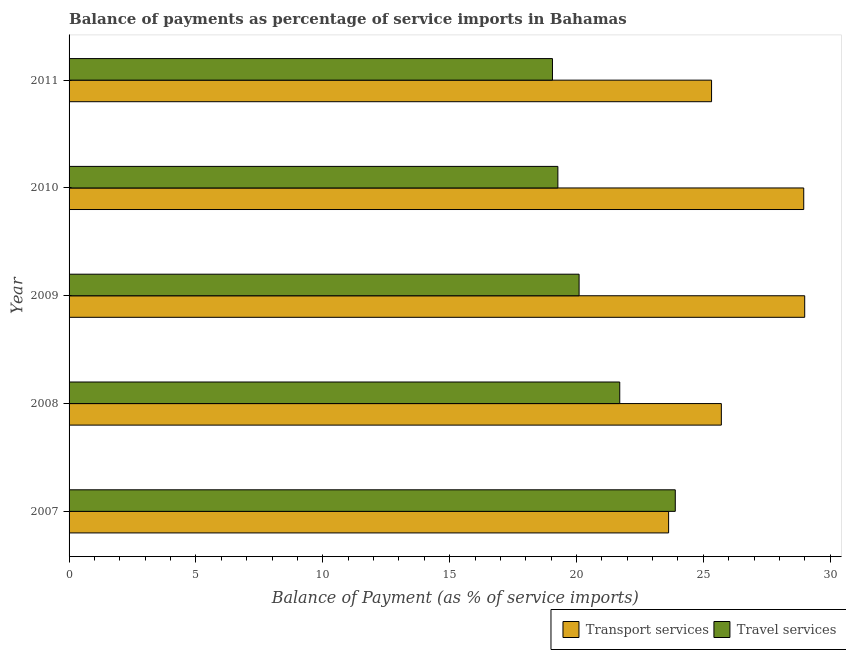How many different coloured bars are there?
Offer a very short reply. 2. How many groups of bars are there?
Offer a terse response. 5. Are the number of bars on each tick of the Y-axis equal?
Your response must be concise. Yes. What is the label of the 3rd group of bars from the top?
Provide a succinct answer. 2009. What is the balance of payments of travel services in 2008?
Ensure brevity in your answer.  21.71. Across all years, what is the maximum balance of payments of travel services?
Provide a succinct answer. 23.89. Across all years, what is the minimum balance of payments of transport services?
Ensure brevity in your answer.  23.63. In which year was the balance of payments of travel services minimum?
Offer a very short reply. 2011. What is the total balance of payments of travel services in the graph?
Make the answer very short. 104.02. What is the difference between the balance of payments of travel services in 2007 and that in 2009?
Keep it short and to the point. 3.79. What is the difference between the balance of payments of travel services in 2011 and the balance of payments of transport services in 2010?
Give a very brief answer. -9.9. What is the average balance of payments of travel services per year?
Give a very brief answer. 20.8. In the year 2010, what is the difference between the balance of payments of travel services and balance of payments of transport services?
Your answer should be compact. -9.69. In how many years, is the balance of payments of transport services greater than 13 %?
Give a very brief answer. 5. What is the ratio of the balance of payments of travel services in 2009 to that in 2011?
Keep it short and to the point. 1.05. Is the balance of payments of transport services in 2010 less than that in 2011?
Your answer should be compact. No. What is the difference between the highest and the second highest balance of payments of transport services?
Ensure brevity in your answer.  0.04. What is the difference between the highest and the lowest balance of payments of travel services?
Give a very brief answer. 4.84. Is the sum of the balance of payments of transport services in 2007 and 2010 greater than the maximum balance of payments of travel services across all years?
Provide a succinct answer. Yes. What does the 2nd bar from the top in 2010 represents?
Your response must be concise. Transport services. What does the 1st bar from the bottom in 2011 represents?
Ensure brevity in your answer.  Transport services. How many bars are there?
Your answer should be compact. 10. Are all the bars in the graph horizontal?
Your response must be concise. Yes. What is the difference between two consecutive major ticks on the X-axis?
Your response must be concise. 5. Where does the legend appear in the graph?
Ensure brevity in your answer.  Bottom right. How many legend labels are there?
Give a very brief answer. 2. What is the title of the graph?
Offer a very short reply. Balance of payments as percentage of service imports in Bahamas. What is the label or title of the X-axis?
Provide a succinct answer. Balance of Payment (as % of service imports). What is the label or title of the Y-axis?
Provide a succinct answer. Year. What is the Balance of Payment (as % of service imports) in Transport services in 2007?
Ensure brevity in your answer.  23.63. What is the Balance of Payment (as % of service imports) in Travel services in 2007?
Give a very brief answer. 23.89. What is the Balance of Payment (as % of service imports) in Transport services in 2008?
Your response must be concise. 25.71. What is the Balance of Payment (as % of service imports) in Travel services in 2008?
Keep it short and to the point. 21.71. What is the Balance of Payment (as % of service imports) in Transport services in 2009?
Provide a succinct answer. 29. What is the Balance of Payment (as % of service imports) in Travel services in 2009?
Provide a succinct answer. 20.1. What is the Balance of Payment (as % of service imports) in Transport services in 2010?
Give a very brief answer. 28.96. What is the Balance of Payment (as % of service imports) in Travel services in 2010?
Your answer should be very brief. 19.27. What is the Balance of Payment (as % of service imports) of Transport services in 2011?
Ensure brevity in your answer.  25.32. What is the Balance of Payment (as % of service imports) in Travel services in 2011?
Your answer should be compact. 19.05. Across all years, what is the maximum Balance of Payment (as % of service imports) of Transport services?
Make the answer very short. 29. Across all years, what is the maximum Balance of Payment (as % of service imports) in Travel services?
Your response must be concise. 23.89. Across all years, what is the minimum Balance of Payment (as % of service imports) of Transport services?
Keep it short and to the point. 23.63. Across all years, what is the minimum Balance of Payment (as % of service imports) of Travel services?
Offer a very short reply. 19.05. What is the total Balance of Payment (as % of service imports) in Transport services in the graph?
Keep it short and to the point. 132.62. What is the total Balance of Payment (as % of service imports) of Travel services in the graph?
Your answer should be compact. 104.02. What is the difference between the Balance of Payment (as % of service imports) in Transport services in 2007 and that in 2008?
Provide a succinct answer. -2.08. What is the difference between the Balance of Payment (as % of service imports) of Travel services in 2007 and that in 2008?
Your answer should be very brief. 2.19. What is the difference between the Balance of Payment (as % of service imports) of Transport services in 2007 and that in 2009?
Give a very brief answer. -5.36. What is the difference between the Balance of Payment (as % of service imports) in Travel services in 2007 and that in 2009?
Keep it short and to the point. 3.79. What is the difference between the Balance of Payment (as % of service imports) of Transport services in 2007 and that in 2010?
Offer a terse response. -5.33. What is the difference between the Balance of Payment (as % of service imports) in Travel services in 2007 and that in 2010?
Ensure brevity in your answer.  4.63. What is the difference between the Balance of Payment (as % of service imports) of Transport services in 2007 and that in 2011?
Offer a terse response. -1.69. What is the difference between the Balance of Payment (as % of service imports) of Travel services in 2007 and that in 2011?
Offer a terse response. 4.84. What is the difference between the Balance of Payment (as % of service imports) of Transport services in 2008 and that in 2009?
Give a very brief answer. -3.29. What is the difference between the Balance of Payment (as % of service imports) of Travel services in 2008 and that in 2009?
Provide a short and direct response. 1.6. What is the difference between the Balance of Payment (as % of service imports) in Transport services in 2008 and that in 2010?
Keep it short and to the point. -3.25. What is the difference between the Balance of Payment (as % of service imports) of Travel services in 2008 and that in 2010?
Your answer should be compact. 2.44. What is the difference between the Balance of Payment (as % of service imports) of Transport services in 2008 and that in 2011?
Offer a terse response. 0.39. What is the difference between the Balance of Payment (as % of service imports) in Travel services in 2008 and that in 2011?
Provide a succinct answer. 2.65. What is the difference between the Balance of Payment (as % of service imports) in Transport services in 2009 and that in 2010?
Your answer should be compact. 0.04. What is the difference between the Balance of Payment (as % of service imports) in Travel services in 2009 and that in 2010?
Your response must be concise. 0.84. What is the difference between the Balance of Payment (as % of service imports) in Transport services in 2009 and that in 2011?
Offer a very short reply. 3.67. What is the difference between the Balance of Payment (as % of service imports) of Travel services in 2009 and that in 2011?
Make the answer very short. 1.05. What is the difference between the Balance of Payment (as % of service imports) of Transport services in 2010 and that in 2011?
Provide a succinct answer. 3.63. What is the difference between the Balance of Payment (as % of service imports) of Travel services in 2010 and that in 2011?
Ensure brevity in your answer.  0.21. What is the difference between the Balance of Payment (as % of service imports) in Transport services in 2007 and the Balance of Payment (as % of service imports) in Travel services in 2008?
Your answer should be very brief. 1.93. What is the difference between the Balance of Payment (as % of service imports) in Transport services in 2007 and the Balance of Payment (as % of service imports) in Travel services in 2009?
Provide a short and direct response. 3.53. What is the difference between the Balance of Payment (as % of service imports) of Transport services in 2007 and the Balance of Payment (as % of service imports) of Travel services in 2010?
Keep it short and to the point. 4.36. What is the difference between the Balance of Payment (as % of service imports) of Transport services in 2007 and the Balance of Payment (as % of service imports) of Travel services in 2011?
Give a very brief answer. 4.58. What is the difference between the Balance of Payment (as % of service imports) of Transport services in 2008 and the Balance of Payment (as % of service imports) of Travel services in 2009?
Ensure brevity in your answer.  5.61. What is the difference between the Balance of Payment (as % of service imports) in Transport services in 2008 and the Balance of Payment (as % of service imports) in Travel services in 2010?
Your answer should be compact. 6.44. What is the difference between the Balance of Payment (as % of service imports) of Transport services in 2008 and the Balance of Payment (as % of service imports) of Travel services in 2011?
Ensure brevity in your answer.  6.66. What is the difference between the Balance of Payment (as % of service imports) in Transport services in 2009 and the Balance of Payment (as % of service imports) in Travel services in 2010?
Give a very brief answer. 9.73. What is the difference between the Balance of Payment (as % of service imports) of Transport services in 2009 and the Balance of Payment (as % of service imports) of Travel services in 2011?
Your response must be concise. 9.94. What is the difference between the Balance of Payment (as % of service imports) of Transport services in 2010 and the Balance of Payment (as % of service imports) of Travel services in 2011?
Offer a very short reply. 9.9. What is the average Balance of Payment (as % of service imports) of Transport services per year?
Ensure brevity in your answer.  26.52. What is the average Balance of Payment (as % of service imports) of Travel services per year?
Give a very brief answer. 20.8. In the year 2007, what is the difference between the Balance of Payment (as % of service imports) of Transport services and Balance of Payment (as % of service imports) of Travel services?
Keep it short and to the point. -0.26. In the year 2008, what is the difference between the Balance of Payment (as % of service imports) in Transport services and Balance of Payment (as % of service imports) in Travel services?
Keep it short and to the point. 4. In the year 2009, what is the difference between the Balance of Payment (as % of service imports) of Transport services and Balance of Payment (as % of service imports) of Travel services?
Your answer should be compact. 8.89. In the year 2010, what is the difference between the Balance of Payment (as % of service imports) of Transport services and Balance of Payment (as % of service imports) of Travel services?
Your response must be concise. 9.69. In the year 2011, what is the difference between the Balance of Payment (as % of service imports) in Transport services and Balance of Payment (as % of service imports) in Travel services?
Ensure brevity in your answer.  6.27. What is the ratio of the Balance of Payment (as % of service imports) of Transport services in 2007 to that in 2008?
Keep it short and to the point. 0.92. What is the ratio of the Balance of Payment (as % of service imports) of Travel services in 2007 to that in 2008?
Give a very brief answer. 1.1. What is the ratio of the Balance of Payment (as % of service imports) of Transport services in 2007 to that in 2009?
Provide a succinct answer. 0.81. What is the ratio of the Balance of Payment (as % of service imports) of Travel services in 2007 to that in 2009?
Offer a very short reply. 1.19. What is the ratio of the Balance of Payment (as % of service imports) of Transport services in 2007 to that in 2010?
Offer a very short reply. 0.82. What is the ratio of the Balance of Payment (as % of service imports) of Travel services in 2007 to that in 2010?
Ensure brevity in your answer.  1.24. What is the ratio of the Balance of Payment (as % of service imports) of Transport services in 2007 to that in 2011?
Your response must be concise. 0.93. What is the ratio of the Balance of Payment (as % of service imports) in Travel services in 2007 to that in 2011?
Provide a short and direct response. 1.25. What is the ratio of the Balance of Payment (as % of service imports) of Transport services in 2008 to that in 2009?
Your answer should be compact. 0.89. What is the ratio of the Balance of Payment (as % of service imports) in Travel services in 2008 to that in 2009?
Your answer should be compact. 1.08. What is the ratio of the Balance of Payment (as % of service imports) of Transport services in 2008 to that in 2010?
Offer a very short reply. 0.89. What is the ratio of the Balance of Payment (as % of service imports) of Travel services in 2008 to that in 2010?
Offer a terse response. 1.13. What is the ratio of the Balance of Payment (as % of service imports) of Transport services in 2008 to that in 2011?
Provide a short and direct response. 1.02. What is the ratio of the Balance of Payment (as % of service imports) in Travel services in 2008 to that in 2011?
Provide a succinct answer. 1.14. What is the ratio of the Balance of Payment (as % of service imports) of Travel services in 2009 to that in 2010?
Your answer should be compact. 1.04. What is the ratio of the Balance of Payment (as % of service imports) in Transport services in 2009 to that in 2011?
Your answer should be compact. 1.15. What is the ratio of the Balance of Payment (as % of service imports) in Travel services in 2009 to that in 2011?
Ensure brevity in your answer.  1.06. What is the ratio of the Balance of Payment (as % of service imports) of Transport services in 2010 to that in 2011?
Make the answer very short. 1.14. What is the ratio of the Balance of Payment (as % of service imports) in Travel services in 2010 to that in 2011?
Provide a succinct answer. 1.01. What is the difference between the highest and the second highest Balance of Payment (as % of service imports) of Transport services?
Keep it short and to the point. 0.04. What is the difference between the highest and the second highest Balance of Payment (as % of service imports) of Travel services?
Your answer should be compact. 2.19. What is the difference between the highest and the lowest Balance of Payment (as % of service imports) of Transport services?
Make the answer very short. 5.36. What is the difference between the highest and the lowest Balance of Payment (as % of service imports) of Travel services?
Keep it short and to the point. 4.84. 